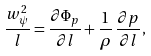<formula> <loc_0><loc_0><loc_500><loc_500>\frac { w ^ { 2 } _ { \psi } } { l } = \frac { \partial \Phi _ { p } } { \partial l } + \frac { 1 } { \rho } \, \frac { \partial p } { \partial l } ,</formula> 